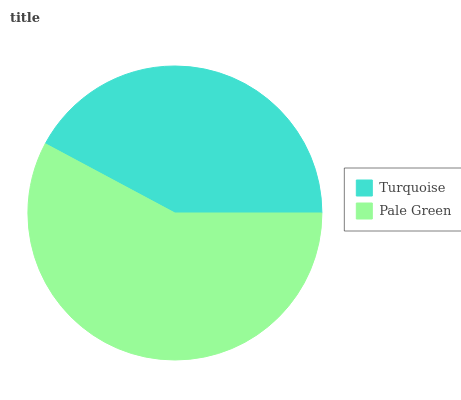Is Turquoise the minimum?
Answer yes or no. Yes. Is Pale Green the maximum?
Answer yes or no. Yes. Is Pale Green the minimum?
Answer yes or no. No. Is Pale Green greater than Turquoise?
Answer yes or no. Yes. Is Turquoise less than Pale Green?
Answer yes or no. Yes. Is Turquoise greater than Pale Green?
Answer yes or no. No. Is Pale Green less than Turquoise?
Answer yes or no. No. Is Pale Green the high median?
Answer yes or no. Yes. Is Turquoise the low median?
Answer yes or no. Yes. Is Turquoise the high median?
Answer yes or no. No. Is Pale Green the low median?
Answer yes or no. No. 